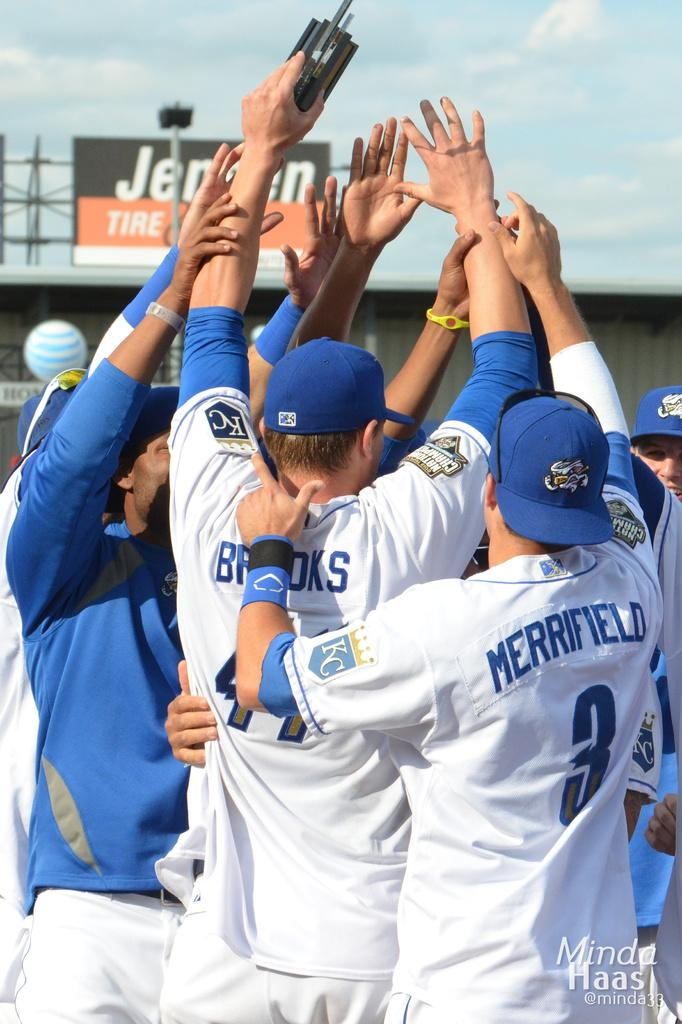<image>
Provide a brief description of the given image. A group of baseball players are huddled together with Brooks and Merrifield in the back. 